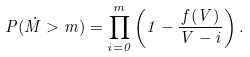<formula> <loc_0><loc_0><loc_500><loc_500>P ( \dot { M } > m ) = \prod _ { i = 0 } ^ { m } \left ( 1 - \frac { f ( V ) } { V - i } \right ) .</formula> 